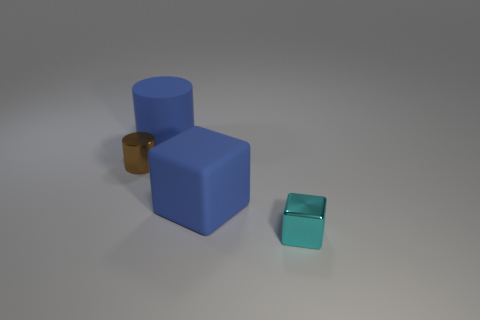Does the rubber thing in front of the large blue matte cylinder have the same shape as the cyan shiny thing?
Provide a short and direct response. Yes. What color is the tiny cylinder that is the same material as the tiny cyan thing?
Offer a terse response. Brown. How many small brown cylinders have the same material as the big blue cube?
Provide a succinct answer. 0. There is a shiny object that is behind the small object that is to the right of the big thing on the left side of the blue rubber cube; what is its color?
Keep it short and to the point. Brown. Do the cyan thing and the brown object have the same size?
Offer a terse response. Yes. What number of objects are either metal things right of the tiny brown cylinder or large red metal cylinders?
Make the answer very short. 1. How many other objects are the same size as the blue matte block?
Give a very brief answer. 1. The matte cylinder is what color?
Your answer should be very brief. Blue. How many tiny objects are either blue objects or blue matte cylinders?
Make the answer very short. 0. Is the size of the blue matte cube that is behind the small metal block the same as the cylinder on the right side of the small brown cylinder?
Provide a short and direct response. Yes. 